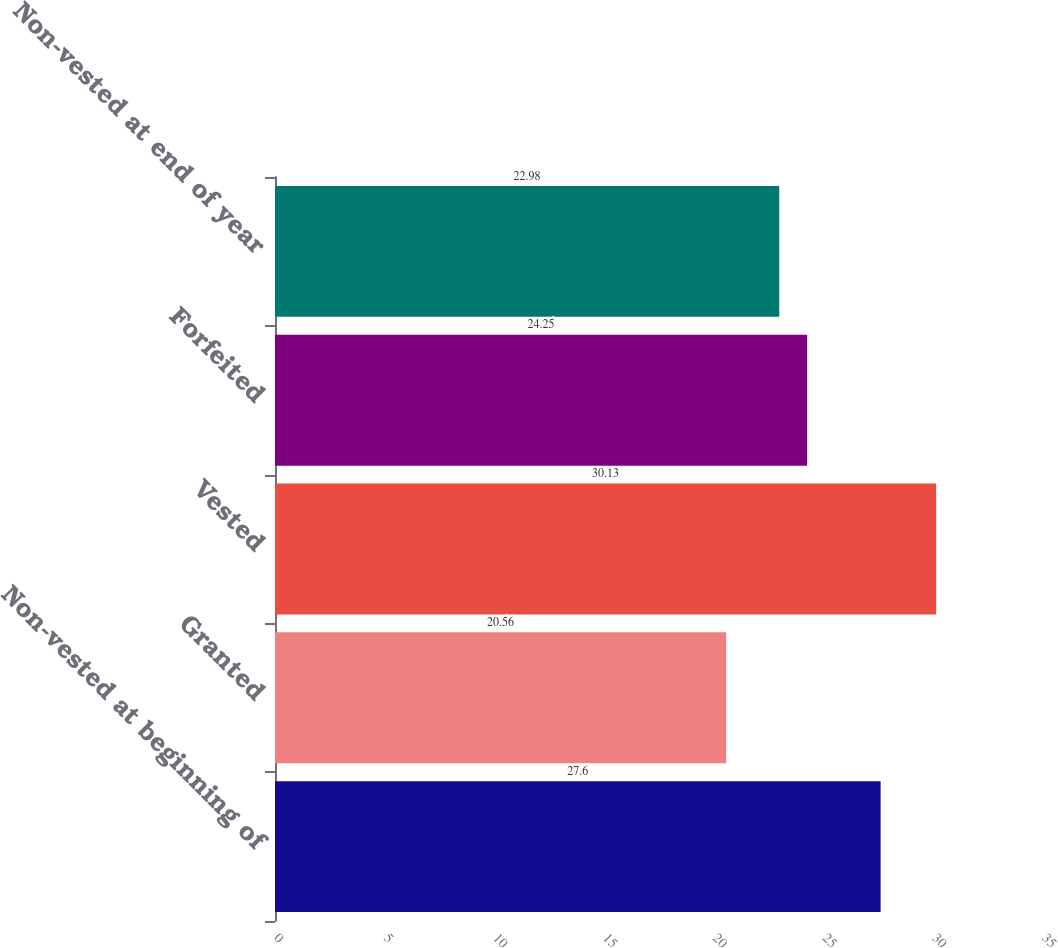Convert chart to OTSL. <chart><loc_0><loc_0><loc_500><loc_500><bar_chart><fcel>Non-vested at beginning of<fcel>Granted<fcel>Vested<fcel>Forfeited<fcel>Non-vested at end of year<nl><fcel>27.6<fcel>20.56<fcel>30.13<fcel>24.25<fcel>22.98<nl></chart> 